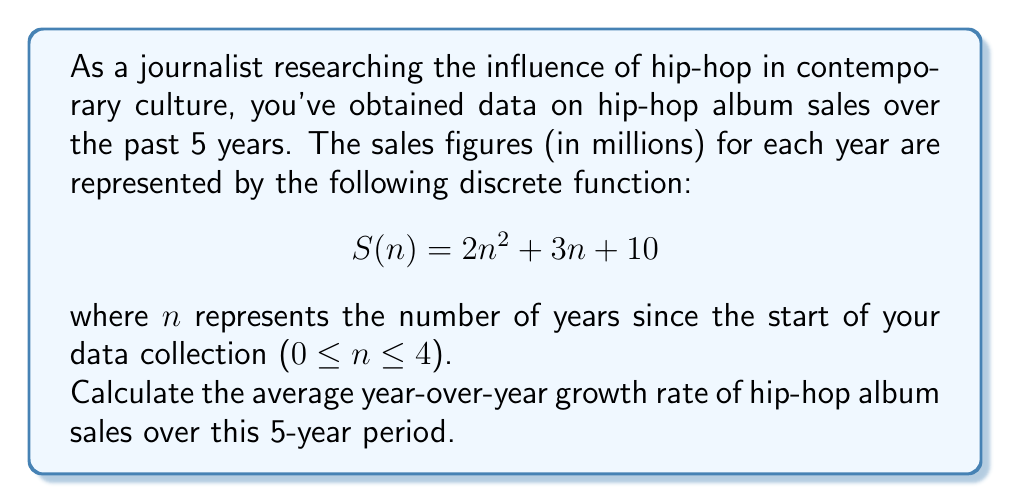Help me with this question. To solve this problem, we'll follow these steps:

1. Calculate the sales figures for each year using the given function.
2. Calculate the year-over-year growth rates.
3. Find the average of these growth rates.

Step 1: Calculate sales figures

For n = 0 to 4:
$$S(0) = 2(0)^2 + 3(0) + 10 = 10$$
$$S(1) = 2(1)^2 + 3(1) + 10 = 15$$
$$S(2) = 2(2)^2 + 3(2) + 10 = 24$$
$$S(3) = 2(3)^2 + 3(3) + 10 = 37$$
$$S(4) = 2(4)^2 + 3(4) + 10 = 54$$

Step 2: Calculate year-over-year growth rates

Growth rate formula: $(\frac{\text{New Value}}{\text{Old Value}} - 1) \times 100\%$

Year 0 to 1: $(\frac{15}{10} - 1) \times 100\% = 50\%$
Year 1 to 2: $(\frac{24}{15} - 1) \times 100\% = 60\%$
Year 2 to 3: $(\frac{37}{24} - 1) \times 100\% \approx 54.17\%$
Year 3 to 4: $(\frac{54}{37} - 1) \times 100\% \approx 45.95\%$

Step 3: Calculate the average growth rate

Average = $\frac{50\% + 60\% + 54.17\% + 45.95\%}{4} \approx 52.53\%$
Answer: The average year-over-year growth rate of hip-hop album sales over the 5-year period is approximately 52.53%. 